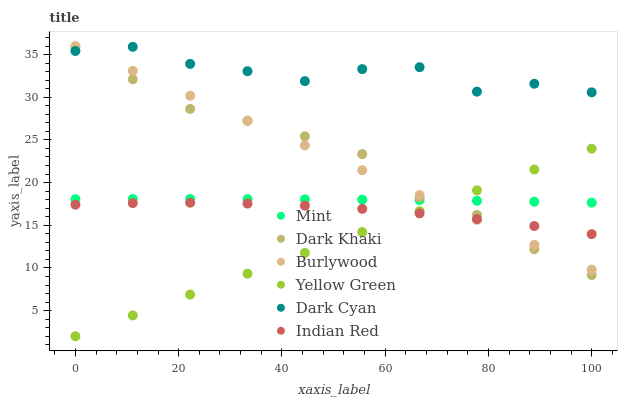Does Yellow Green have the minimum area under the curve?
Answer yes or no. Yes. Does Dark Cyan have the maximum area under the curve?
Answer yes or no. Yes. Does Burlywood have the minimum area under the curve?
Answer yes or no. No. Does Burlywood have the maximum area under the curve?
Answer yes or no. No. Is Yellow Green the smoothest?
Answer yes or no. Yes. Is Dark Cyan the roughest?
Answer yes or no. Yes. Is Burlywood the smoothest?
Answer yes or no. No. Is Burlywood the roughest?
Answer yes or no. No. Does Yellow Green have the lowest value?
Answer yes or no. Yes. Does Burlywood have the lowest value?
Answer yes or no. No. Does Burlywood have the highest value?
Answer yes or no. Yes. Does Dark Khaki have the highest value?
Answer yes or no. No. Is Indian Red less than Dark Cyan?
Answer yes or no. Yes. Is Dark Cyan greater than Indian Red?
Answer yes or no. Yes. Does Dark Khaki intersect Mint?
Answer yes or no. Yes. Is Dark Khaki less than Mint?
Answer yes or no. No. Is Dark Khaki greater than Mint?
Answer yes or no. No. Does Indian Red intersect Dark Cyan?
Answer yes or no. No. 